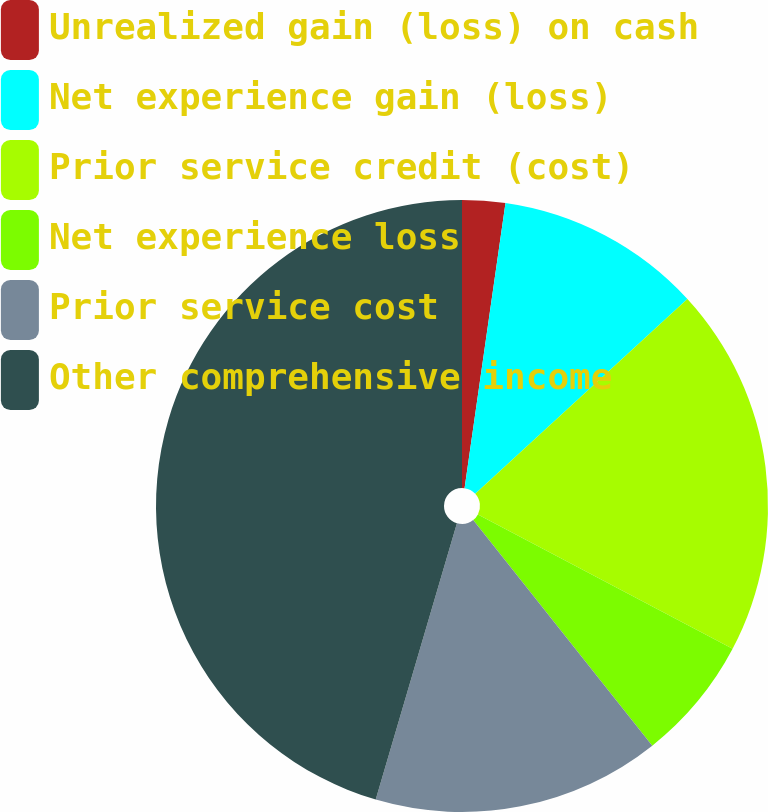Convert chart to OTSL. <chart><loc_0><loc_0><loc_500><loc_500><pie_chart><fcel>Unrealized gain (loss) on cash<fcel>Net experience gain (loss)<fcel>Prior service credit (cost)<fcel>Net experience loss<fcel>Prior service cost<fcel>Other comprehensive income<nl><fcel>2.27%<fcel>10.91%<fcel>19.55%<fcel>6.59%<fcel>15.23%<fcel>45.45%<nl></chart> 